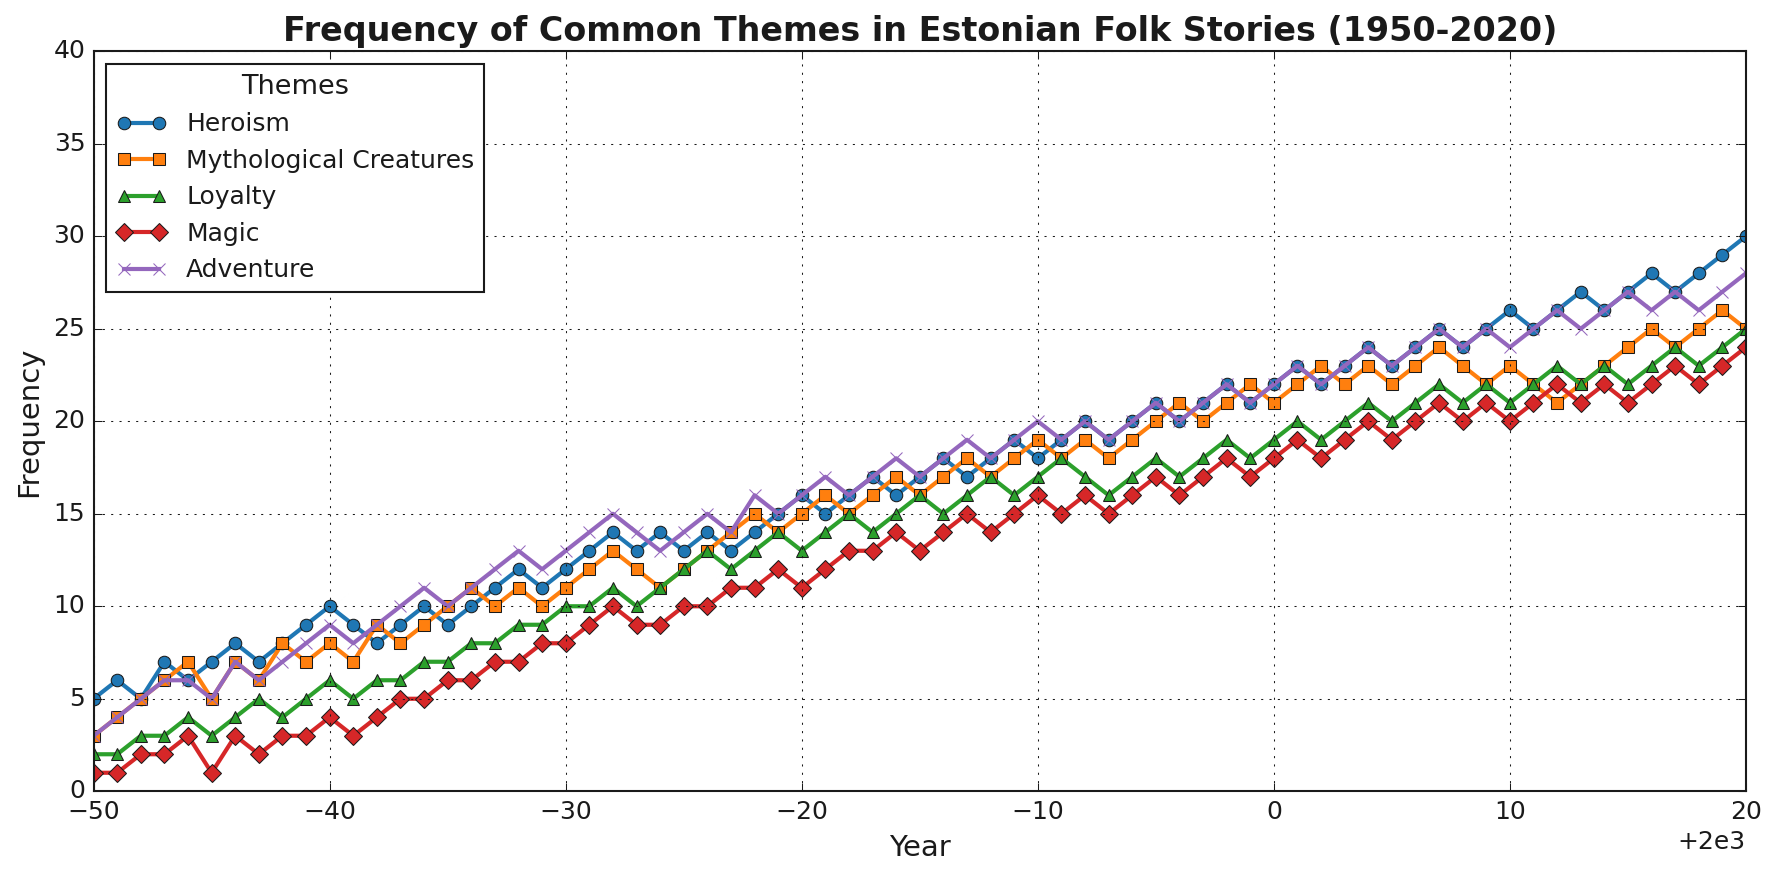What is the frequency of "Heroism" in 1965, and how does it compare to "Mythological Creatures" in the same year? The frequency of "Heroism" in 1965 is 9, while the frequency of "Mythological Creatures" in the same year is 10. Therefore, "Mythological Creatures" had a higher frequency than "Heroism" in 1965.
Answer: Mythological Creatures is higher by 1 Over which year interval did "Adventure" see the largest increase in frequency? To determine the largest increase in frequency, look for the largest difference between consecutive years’ data. Between 1971 (14) and 1972 (15), there's an increase of 1, but between 1991 (19) and 1992 (20), there is an increase of 1 again. The largest increase happens between 2012 (25) and 2013 (28) with an increase of 3.
Answer: 2012 to 2013 Which theme had the highest frequency overall during 1950 to 2020, and what was its value? By looking at the peaks in the graph, "Heroism" appears to have the highest frequency overall in 2020 at 30.
Answer: Heroism, 30 How did the frequency of "Magic" change from 1974 to 1976? Check the frequency values for "Magic" in 1974, 1975, and 1976. In 1974, it was 9; in 1975, it was 10; and in 1976, it was 10. This indicates a steady increase of 1.
Answer: Increased by 1 What was the overall trend for "Mythological Creatures" from 1950 to 2020? Observing the graph, the general trend for "Mythological Creatures" shows an increase from 1950 to 2020, starting at 3 in 1950 and reaching 25 in 2020.
Answer: Increasing trend Which theme had the least variation in frequency over the years? Analyze the frequency lines for "Heroism," "Mythological Creatures," "Loyalty," "Magic," and "Adventure." "Magic" appears relatively stable with less variation than others.
Answer: Magic Between "Loyalty" and "Magic", which had a greater frequency in the year 1980? Check the values for "Loyalty" and "Magic" in 1980. "Loyalty" had a frequency of 13 and "Magic" had a frequency of 11, so "Loyalty" had the greater frequency.
Answer: Loyalty What was the frequency difference between "Heroism" and "Adventure" in 1960? In 1960, "Heroism" had a frequency of 10 and "Adventure" had a frequency of 9, resulting in a difference of 1.
Answer: 1 When did "Loyalty" first surpass a frequency of 20? Analyze the line for "Loyalty." The frequency first surpasses 20 in 2004.
Answer: 2004 